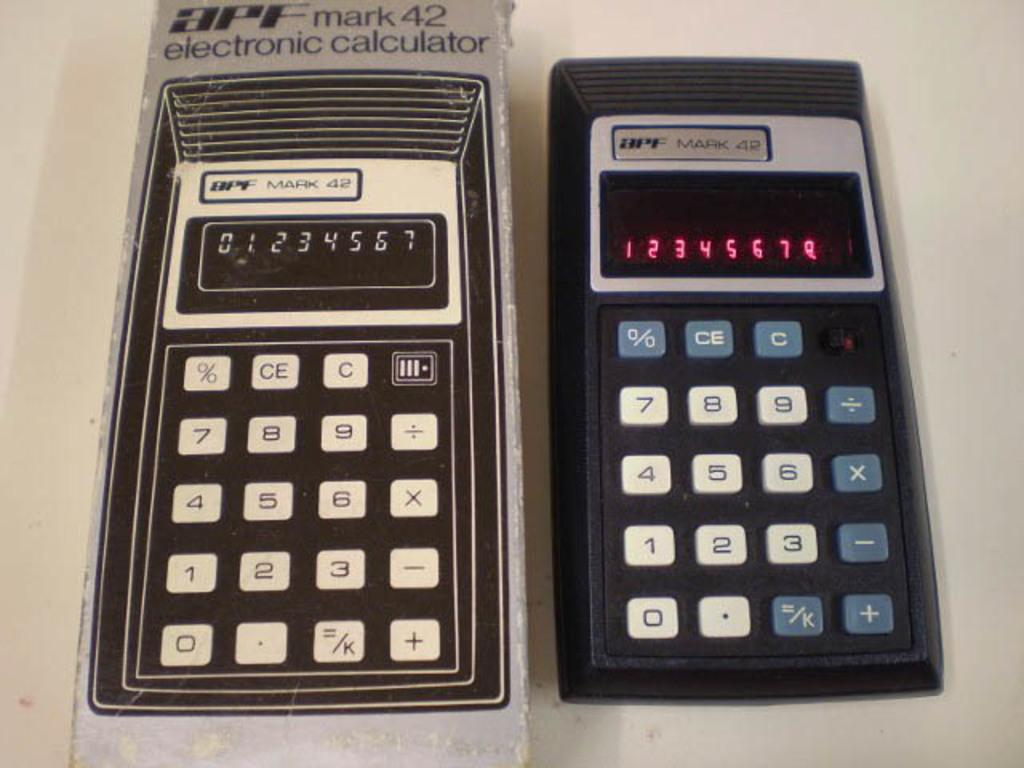<image>
Provide a brief description of the given image. A pair of APF Mark 42 calculators are both turned on and displaying numbers. 